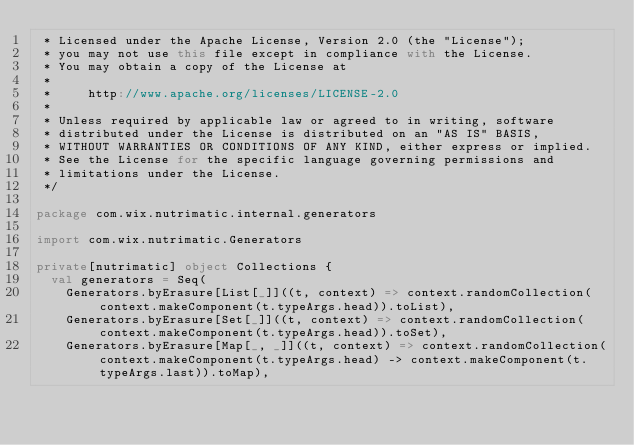<code> <loc_0><loc_0><loc_500><loc_500><_Scala_> * Licensed under the Apache License, Version 2.0 (the "License");
 * you may not use this file except in compliance with the License.
 * You may obtain a copy of the License at
 *
 *     http://www.apache.org/licenses/LICENSE-2.0
 *
 * Unless required by applicable law or agreed to in writing, software
 * distributed under the License is distributed on an "AS IS" BASIS,
 * WITHOUT WARRANTIES OR CONDITIONS OF ANY KIND, either express or implied.
 * See the License for the specific language governing permissions and
 * limitations under the License.
 */

package com.wix.nutrimatic.internal.generators

import com.wix.nutrimatic.Generators

private[nutrimatic] object Collections {
  val generators = Seq(
    Generators.byErasure[List[_]]((t, context) => context.randomCollection(context.makeComponent(t.typeArgs.head)).toList),
    Generators.byErasure[Set[_]]((t, context) => context.randomCollection(context.makeComponent(t.typeArgs.head)).toSet),
    Generators.byErasure[Map[_, _]]((t, context) => context.randomCollection(context.makeComponent(t.typeArgs.head) -> context.makeComponent(t.typeArgs.last)).toMap),</code> 